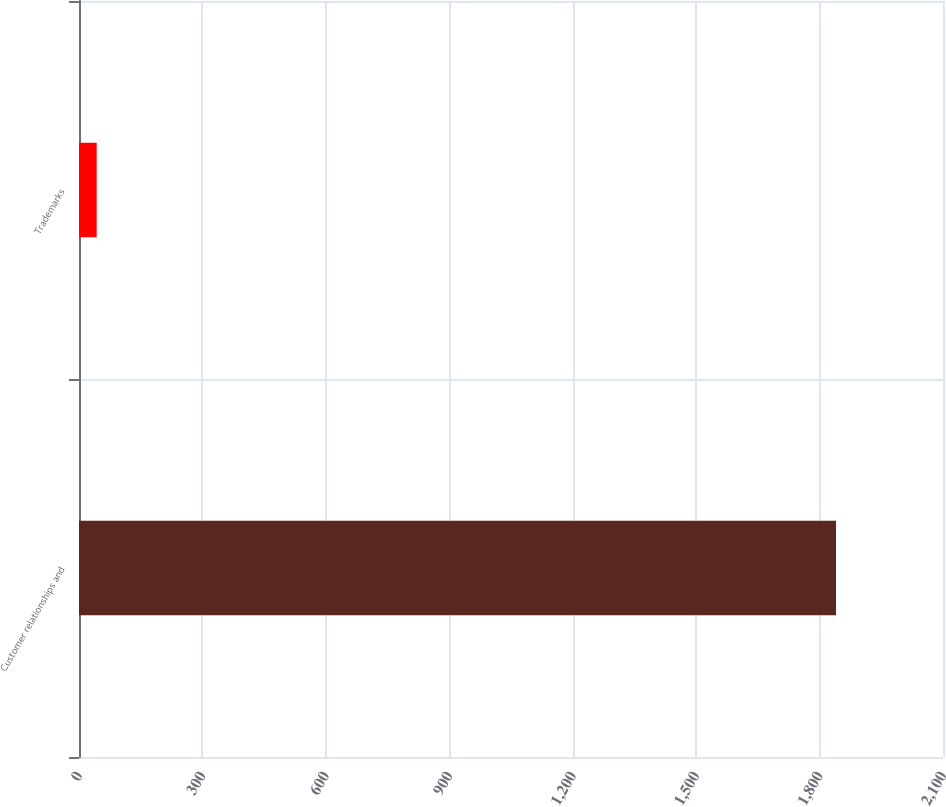Convert chart to OTSL. <chart><loc_0><loc_0><loc_500><loc_500><bar_chart><fcel>Customer relationships and<fcel>Trademarks<nl><fcel>1840<fcel>43<nl></chart> 